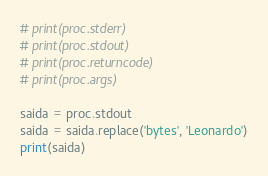Convert code to text. <code><loc_0><loc_0><loc_500><loc_500><_Python_># print(proc.stderr)
# print(proc.stdout)
# print(proc.returncode)
# print(proc.args)

saida = proc.stdout
saida = saida.replace('bytes', 'Leonardo')
print(saida)</code> 